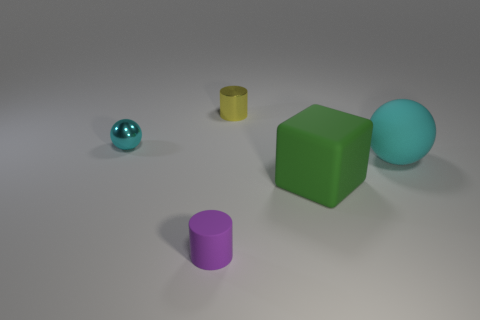Subtract all green cylinders. Subtract all brown spheres. How many cylinders are left? 2 Add 2 yellow cylinders. How many objects exist? 7 Subtract all cubes. How many objects are left? 4 Subtract 0 gray blocks. How many objects are left? 5 Subtract all cubes. Subtract all green objects. How many objects are left? 3 Add 1 tiny cyan things. How many tiny cyan things are left? 2 Add 1 big green blocks. How many big green blocks exist? 2 